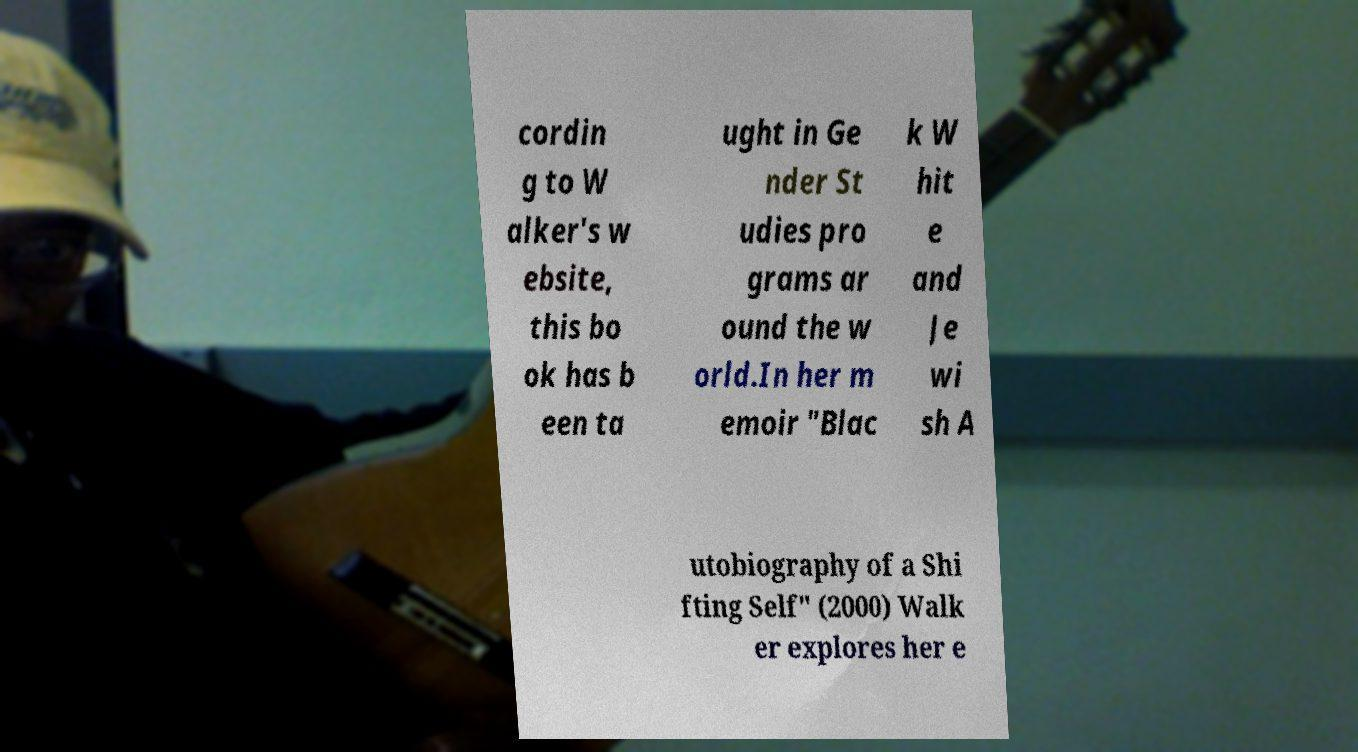Can you read and provide the text displayed in the image?This photo seems to have some interesting text. Can you extract and type it out for me? cordin g to W alker's w ebsite, this bo ok has b een ta ught in Ge nder St udies pro grams ar ound the w orld.In her m emoir "Blac k W hit e and Je wi sh A utobiography of a Shi fting Self" (2000) Walk er explores her e 